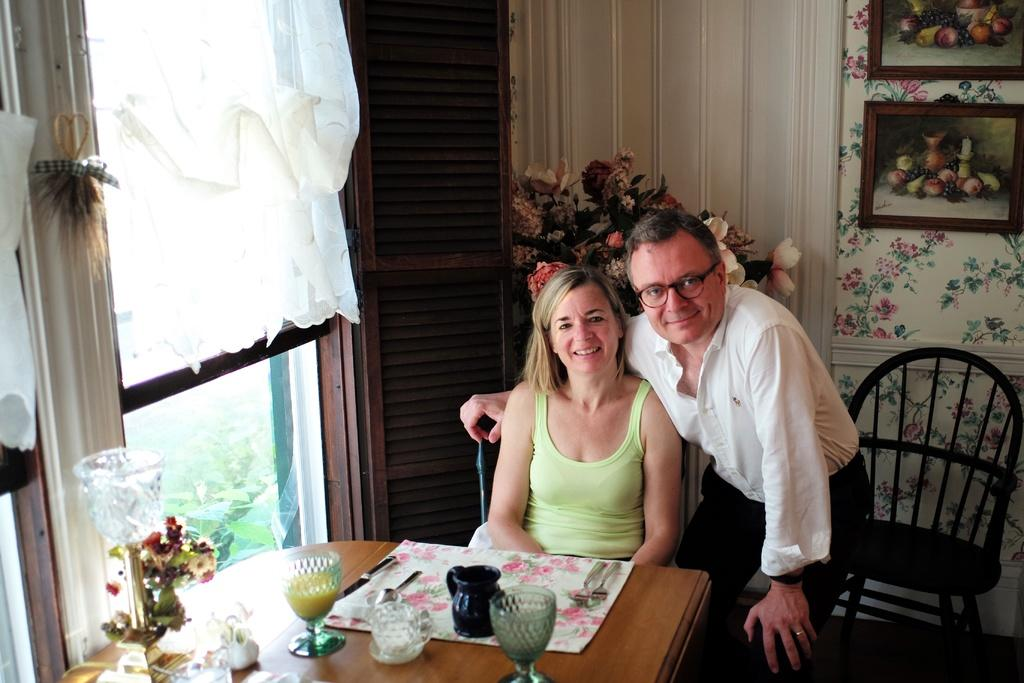How many people are in the image? There are two people in the image. What can be seen on the windows in the image? There are curtains present in the image. What type of decorative items can be seen in the image? Flower pots and frames attached to the wall are visible in the image. What utensils are present in the image? Spoons and glasses are visible in the image. What is on the table in the image? There are objects on the table in the image. How many cakes are being prepared by the girl in the image? There is no girl present in the image, and no cakes are being prepared. 